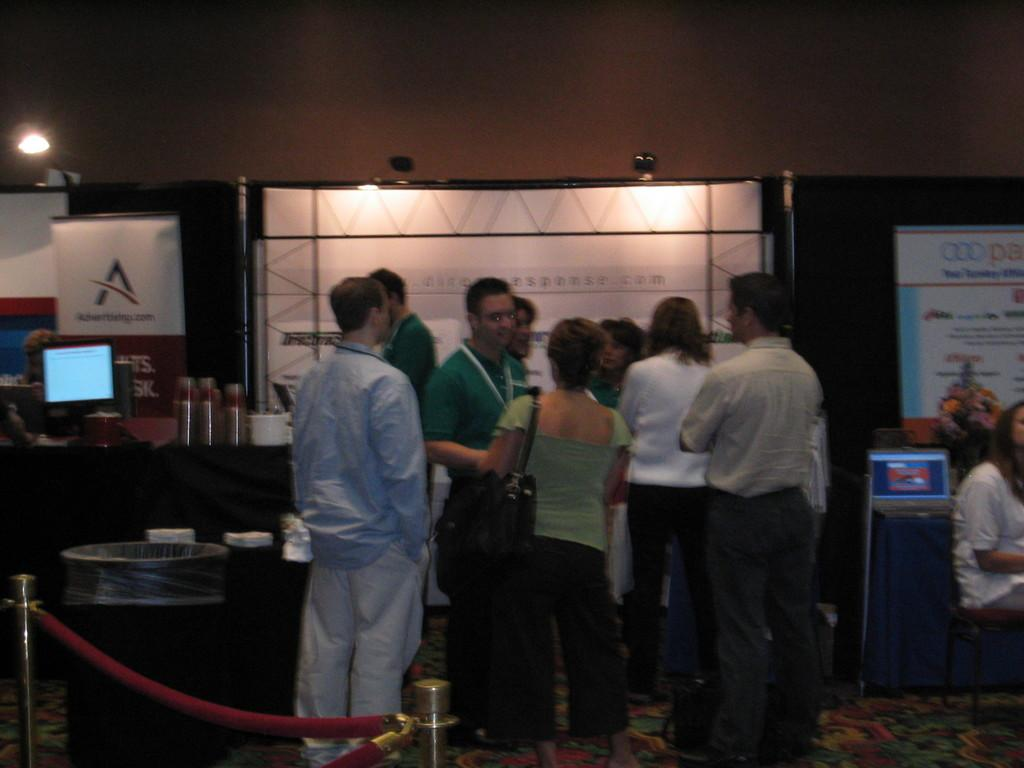How many people are visible in the image? There are people standing in the image. What are the people wearing? The people are wearing clothes. What type of flooring is present in the image? There is a carpet in the image. What type of furniture is present in the image? There is a stool in the image. What type of waste receptacle is present in the image? There is a dustbin in the image. What type of vertical structure is present in the image? There is a pole in the image. What type of display device is present in the image? There is a screen in the image. What type of wall decoration is present in the image? There is a poster in the image. What type of lighting is present in the image? There are lights in the image. What type of booklet is present in the image? There is a flower booklet in the image. Is it raining in the image? There is no indication of rain in the image. Is this a bedroom scene in the image? The image does not provide enough information to determine if it is a bedroom scene. Are the people in the image on vacation? There is no indication of a vacation in the image. 